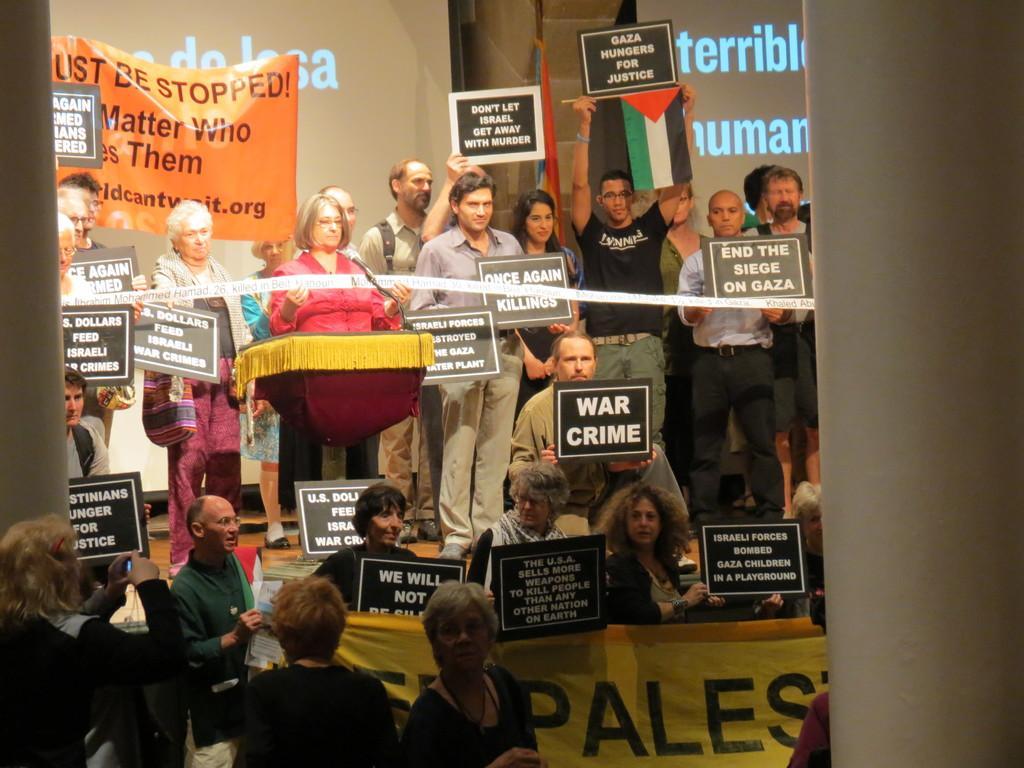Could you give a brief overview of what you see in this image? In this picture I can see couple of people holding boards in their hands and on the right and left side of the image I can see two pillars. Here is a man who is holding a flag along with the board. I can see two screens on the left and right side of the picture and I can see a banner on the left side screen and I can see a banner at the bottom of the picture. 